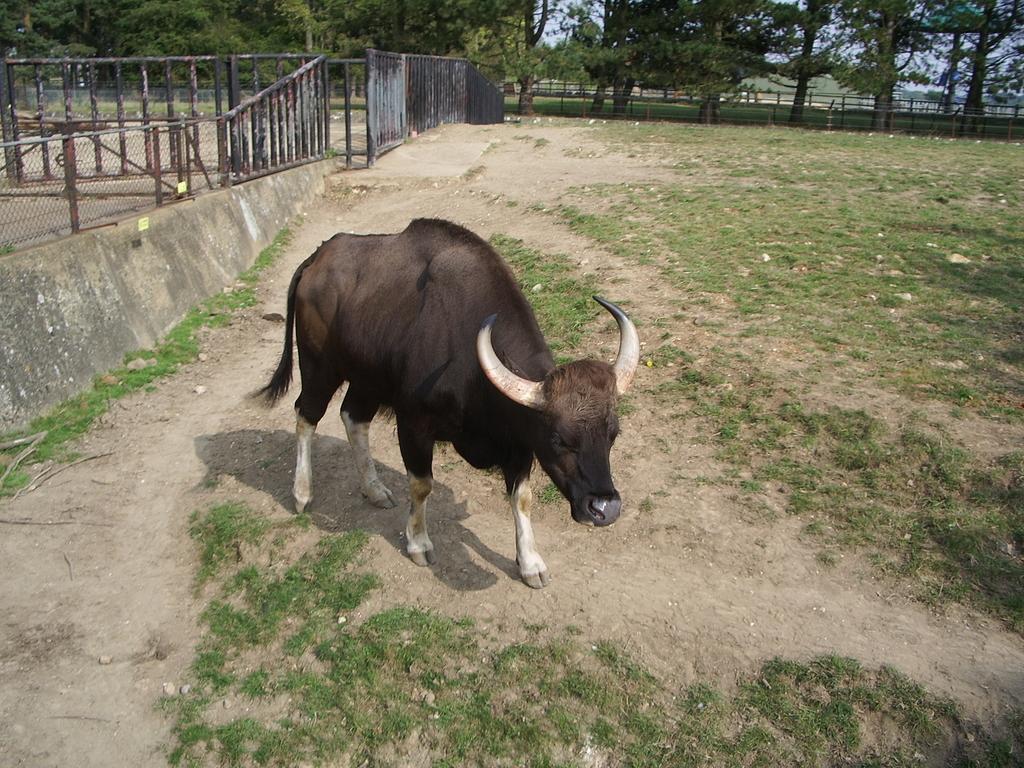Please provide a concise description of this image. In this picture there is a bison in the center of the image and there is a boundary in the top left side of the image and there are trees at the top side of the image. 